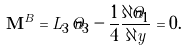<formula> <loc_0><loc_0><loc_500><loc_500>\mathbf M ^ { B } = L _ { 3 } \, \hat { n } _ { 3 } - \frac { 1 } { 4 } \frac { \partial \hat { n } _ { 1 } } { \partial y } = 0 .</formula> 